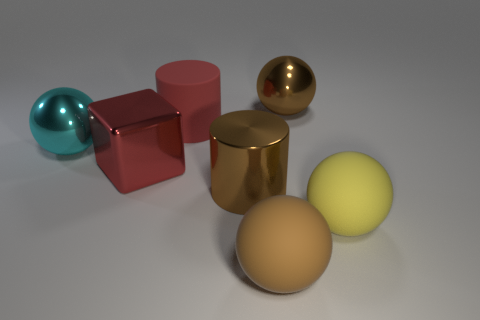How many other things are made of the same material as the large yellow thing? Based on the visual characteristics, there appears to be one other object that is made of similar material as the large yellow sphere - it's the small yellow sphere. They both share a matte surface texture and a similar hue, indicating that they could be composed of the same material. 